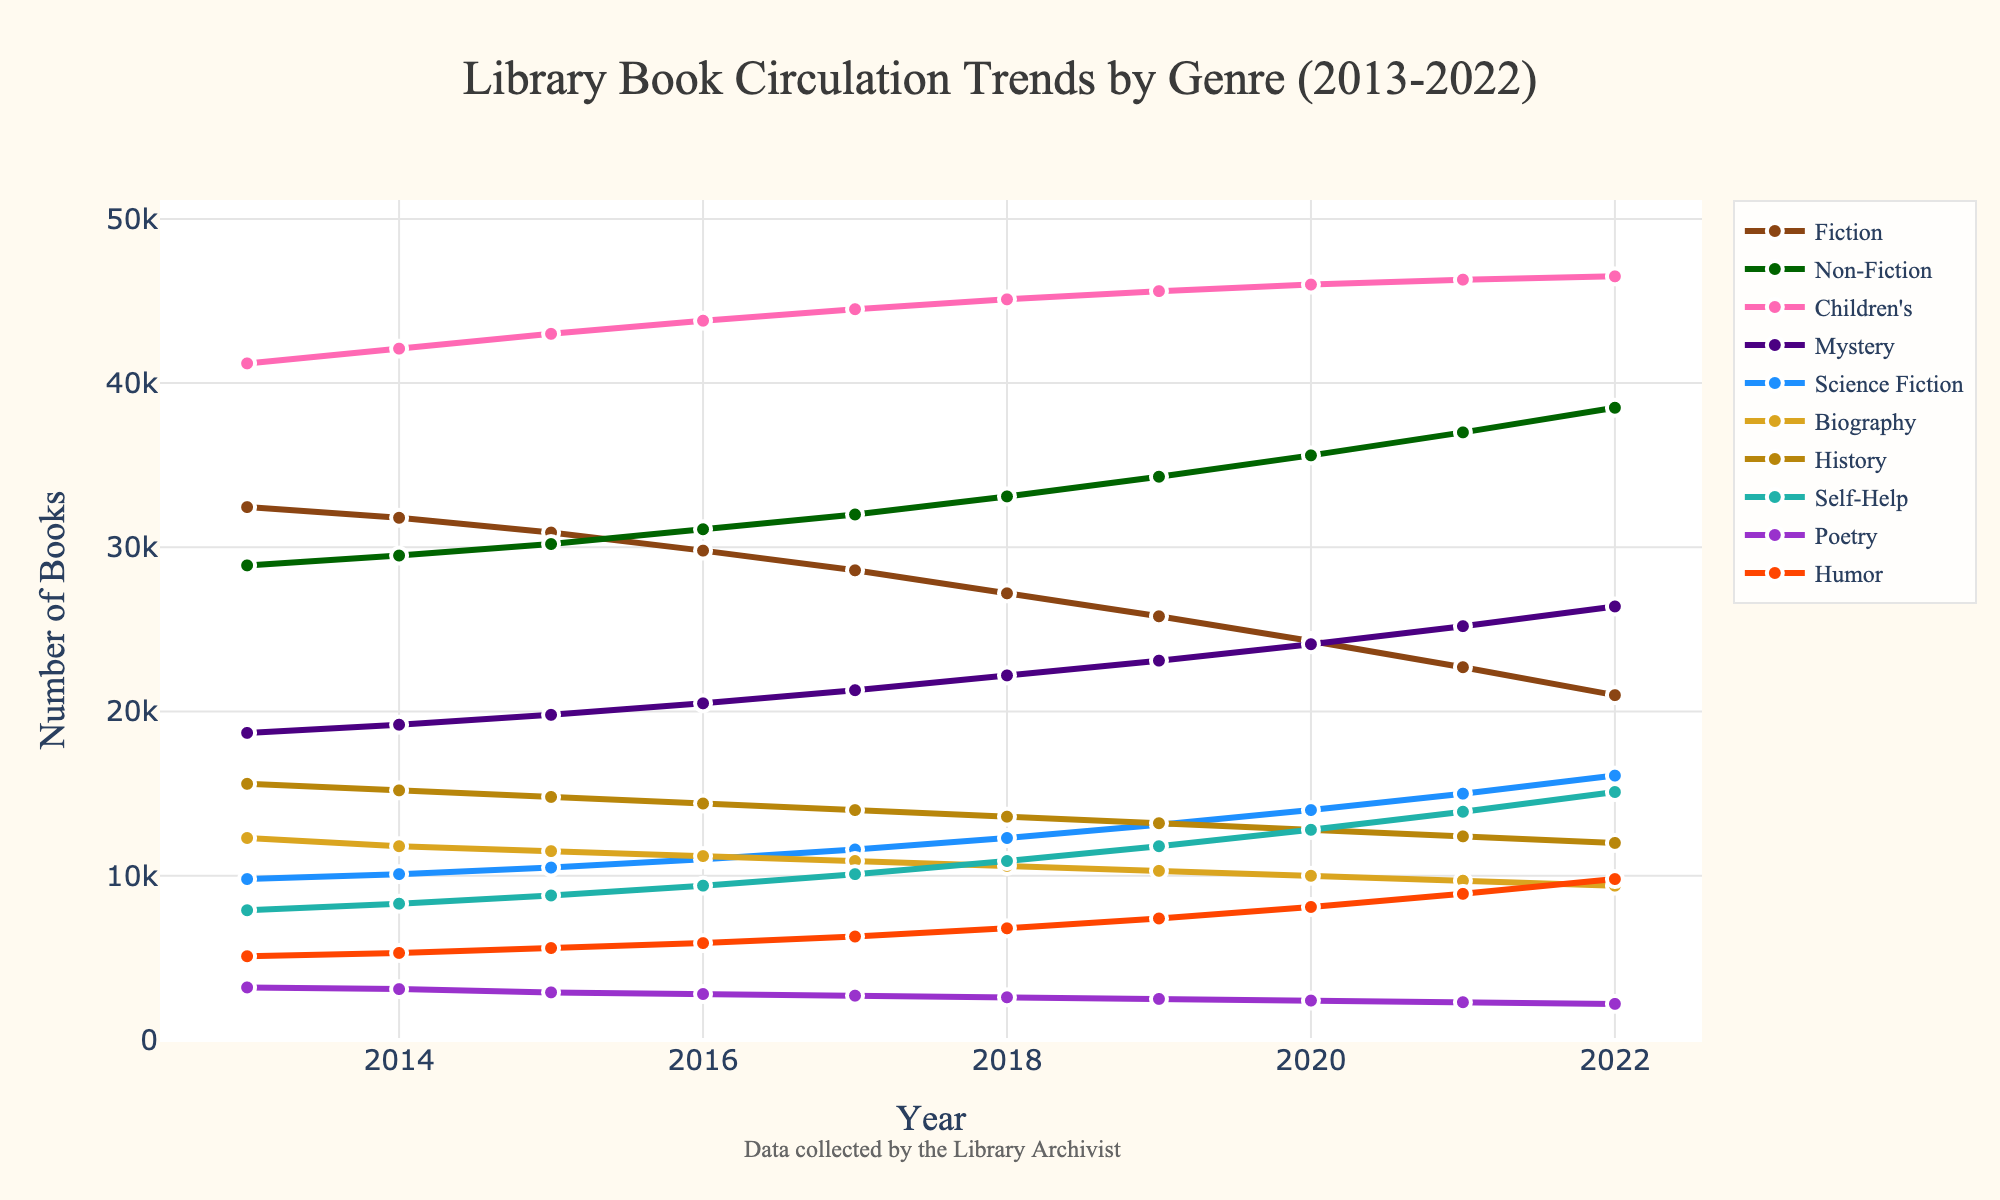What's the average circulation rate for Children's genre over the decade? Sum the circulation rates from 2013 to 2022 for Children's genre: 41200 + 42100 + 43000 + 43800 + 44500 + 45100 + 45600 + 46000 + 46300 + 46500 = 440100. Divide by the number of years (10) to get the average: 440100 / 10 = 44010
Answer: 44010 Which genre had the highest increase in circulation rates over the entire period? Calculate the difference between the circulation rates in 2022 and 2013 for each genre and identify the one with the largest increase. The increases are: Fiction: 21000 - 32450 = -11450, Non-Fiction: 38500 - 28900 = 9600, Children's: 46500 - 41200 = 5300, Mystery: 26400 - 18700 = 7700, Science Fiction: 16100 - 9800 = 6300, Biography: 9400 - 12300 = -2900, History: 12000 - 15600 = -3600, Self-Help: 15100 - 7900 = 7200, Poetry: 2200 - 3200 = -1000, Humor: 9800 - 5100 = 4700. Non-Fiction had the highest increase
Answer: Non-Fiction In which year did Humor genre have the largest circulation rate? Look at the circulation rates for Humor genre across all years and find the year with the highest value. The highest value is 9800 in 2022
Answer: 2022 Compare the circulation rates of Fiction and Mystery genres in 2017. Which is higher? Refer to the 2017 data points for Fiction (28600) and Mystery (21300). Fiction is higher
Answer: Fiction What is the difference in circulation rates between Non-Fiction and Poetry in 2020? Determine the values for Non-Fiction (35600) and Poetry (2400) in 2020 and calculate the difference: 35600 - 2400 = 33200
Answer: 33200 Which genre had the lowest circulation in 2019? Find the lowest value in 2019 across all genres. Poetry had the lowest circulation rate at 2500
Answer: Poetry On average, how much did the circulation rates of Science Fiction and Humor genres change per year between 2013 and 2022? Calculate the total change for each genre over the period and divide by 9 (since there are 9 intervals). For Science Fiction: (16100 - 9800) / 9 = 700 / 9 ≈ 78, and for Humor (9800 - 5100) / 9 = 4700 / 9 ≈ 522. Thus, Science Fiction's average change per year is approximately 78, and Humor's is approximately 522
Answer: Science Fiction: 78, Humor: 522 How does the trend of Biography genre's circulation compare to the overall direction of other genres? Analyze the overall trend by seeing if the circulation rate of Biography increased or decreased. Biography shows a decreasing trend overall (-2900) while most other genres show a growing trend. Compare it to those with rising patterns like Non-Fiction and Mystery, which show clear increases
Answer: Decreasing trend Which genre showed the sharpest decline in circulation rates between any two consecutive years? Identify the largest negative difference between two consecutive years for any genre. Fiction between 2020 (24300) and 2021 (22700) shows a sharp decline of 24300 - 22700 = 1600
Answer: Fiction 